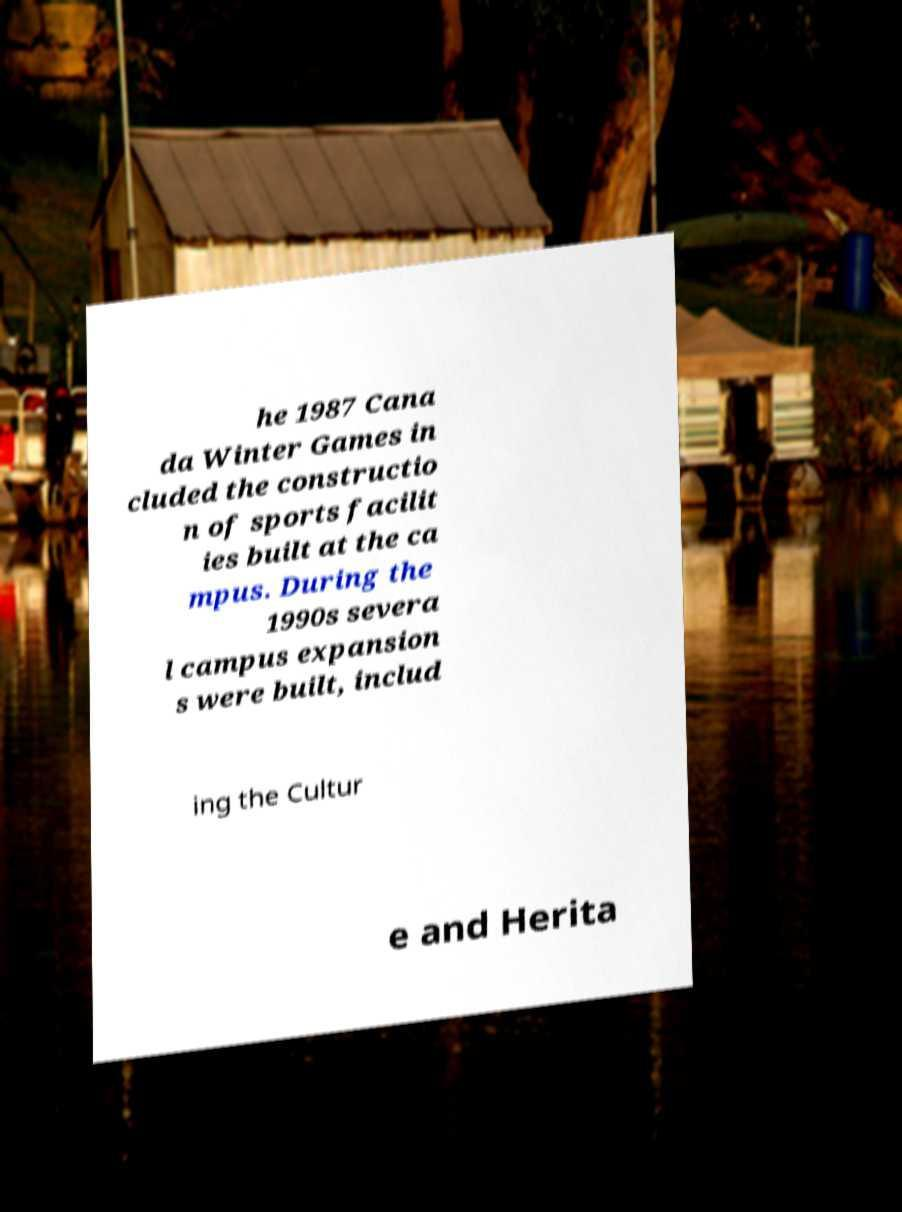Please read and relay the text visible in this image. What does it say? he 1987 Cana da Winter Games in cluded the constructio n of sports facilit ies built at the ca mpus. During the 1990s severa l campus expansion s were built, includ ing the Cultur e and Herita 